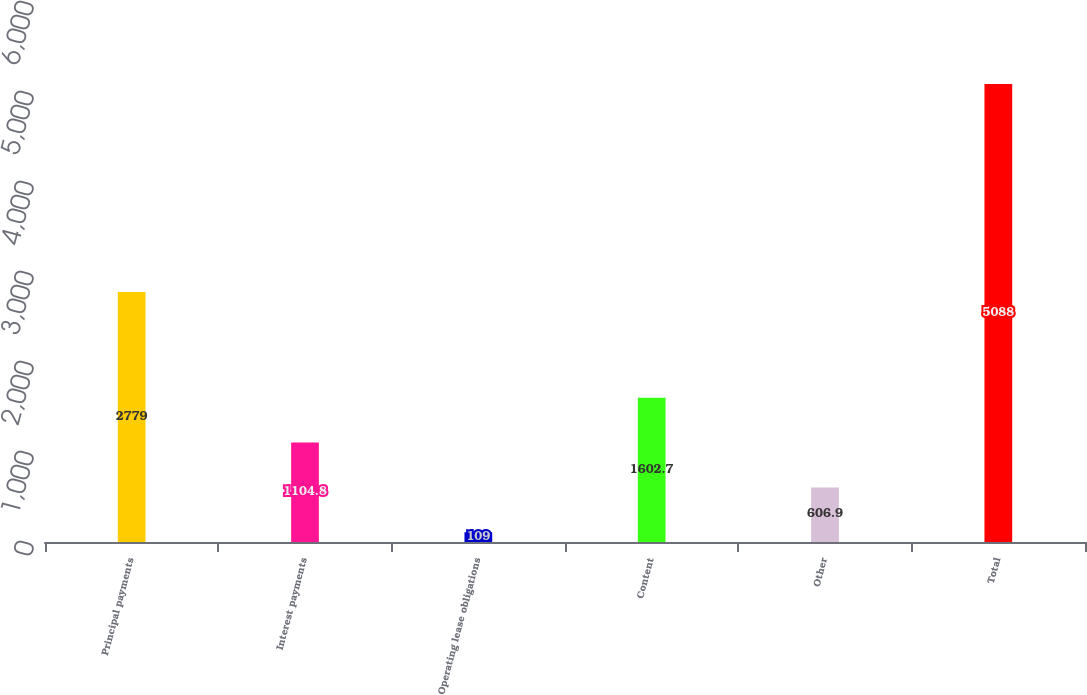Convert chart. <chart><loc_0><loc_0><loc_500><loc_500><bar_chart><fcel>Principal payments<fcel>Interest payments<fcel>Operating lease obligations<fcel>Content<fcel>Other<fcel>Total<nl><fcel>2779<fcel>1104.8<fcel>109<fcel>1602.7<fcel>606.9<fcel>5088<nl></chart> 